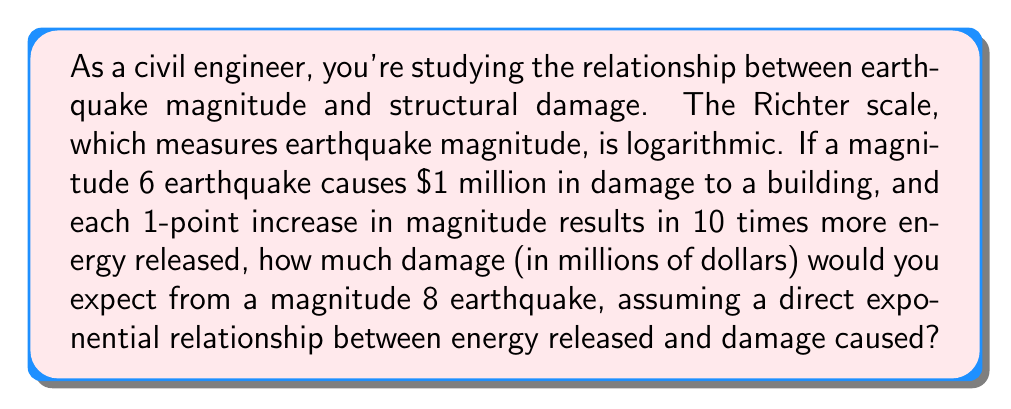Show me your answer to this math problem. Let's approach this step-by-step:

1) First, we need to understand the relationship between earthquake magnitude and energy released:
   - Each 1-point increase in magnitude results in 10 times more energy released.

2) We're looking at the difference between a magnitude 6 and a magnitude 8 earthquake:
   $8 - 6 = 2$ point increase

3) This means the energy released increases by a factor of:
   $10^2 = 100$

4) Now, let's set up our equation:
   Let $x$ be the damage caused by the magnitude 8 earthquake.
   
   $$\frac{x}{1} = 100^1$$

   This is because the ratio of damage should equal the ratio of energy released.

5) Solving for $x$:
   $x = 100 \cdot 1 = 100$

6) Therefore, the damage caused by a magnitude 8 earthquake would be $100 million.

This exponential relationship highlights why even small increases in earthquake magnitude can lead to dramatically more severe consequences, emphasizing the importance of resilient structural design in earthquake-prone areas.
Answer: $100 million 